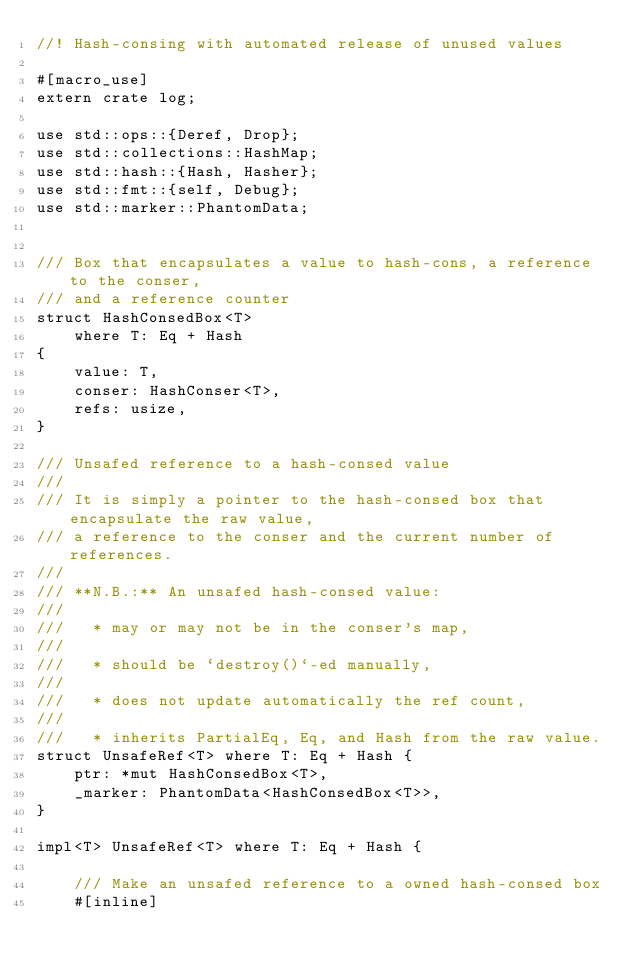Convert code to text. <code><loc_0><loc_0><loc_500><loc_500><_Rust_>//! Hash-consing with automated release of unused values

#[macro_use]
extern crate log;

use std::ops::{Deref, Drop};
use std::collections::HashMap;
use std::hash::{Hash, Hasher};
use std::fmt::{self, Debug};
use std::marker::PhantomData;


/// Box that encapsulates a value to hash-cons, a reference to the conser,
/// and a reference counter
struct HashConsedBox<T>
    where T: Eq + Hash
{
    value: T,
    conser: HashConser<T>,
    refs: usize,
}

/// Unsafed reference to a hash-consed value
///
/// It is simply a pointer to the hash-consed box that encapsulate the raw value,
/// a reference to the conser and the current number of references.
///
/// **N.B.:** An unsafed hash-consed value:
///
///   * may or may not be in the conser's map,
///
///   * should be `destroy()`-ed manually,
///
///   * does not update automatically the ref count,
///
///   * inherits PartialEq, Eq, and Hash from the raw value.
struct UnsafeRef<T> where T: Eq + Hash {
    ptr: *mut HashConsedBox<T>,
    _marker: PhantomData<HashConsedBox<T>>,
}

impl<T> UnsafeRef<T> where T: Eq + Hash {

    /// Make an unsafed reference to a owned hash-consed box
    #[inline]</code> 